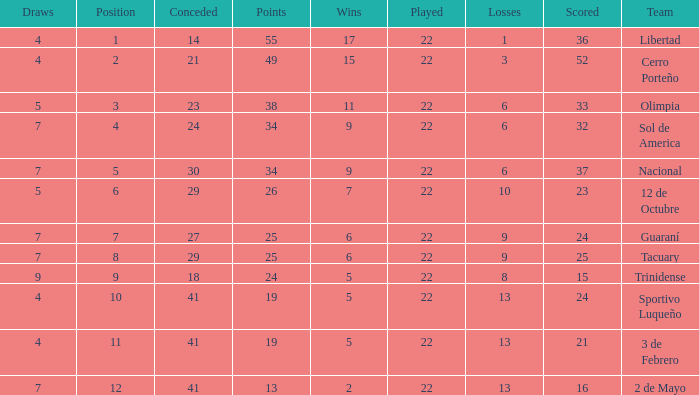What is the number of draws for the team with more than 8 losses and 13 points? 7.0. Help me parse the entirety of this table. {'header': ['Draws', 'Position', 'Conceded', 'Points', 'Wins', 'Played', 'Losses', 'Scored', 'Team'], 'rows': [['4', '1', '14', '55', '17', '22', '1', '36', 'Libertad'], ['4', '2', '21', '49', '15', '22', '3', '52', 'Cerro Porteño'], ['5', '3', '23', '38', '11', '22', '6', '33', 'Olimpia'], ['7', '4', '24', '34', '9', '22', '6', '32', 'Sol de America'], ['7', '5', '30', '34', '9', '22', '6', '37', 'Nacional'], ['5', '6', '29', '26', '7', '22', '10', '23', '12 de Octubre'], ['7', '7', '27', '25', '6', '22', '9', '24', 'Guaraní'], ['7', '8', '29', '25', '6', '22', '9', '25', 'Tacuary'], ['9', '9', '18', '24', '5', '22', '8', '15', 'Trinidense'], ['4', '10', '41', '19', '5', '22', '13', '24', 'Sportivo Luqueño'], ['4', '11', '41', '19', '5', '22', '13', '21', '3 de Febrero'], ['7', '12', '41', '13', '2', '22', '13', '16', '2 de Mayo']]} 